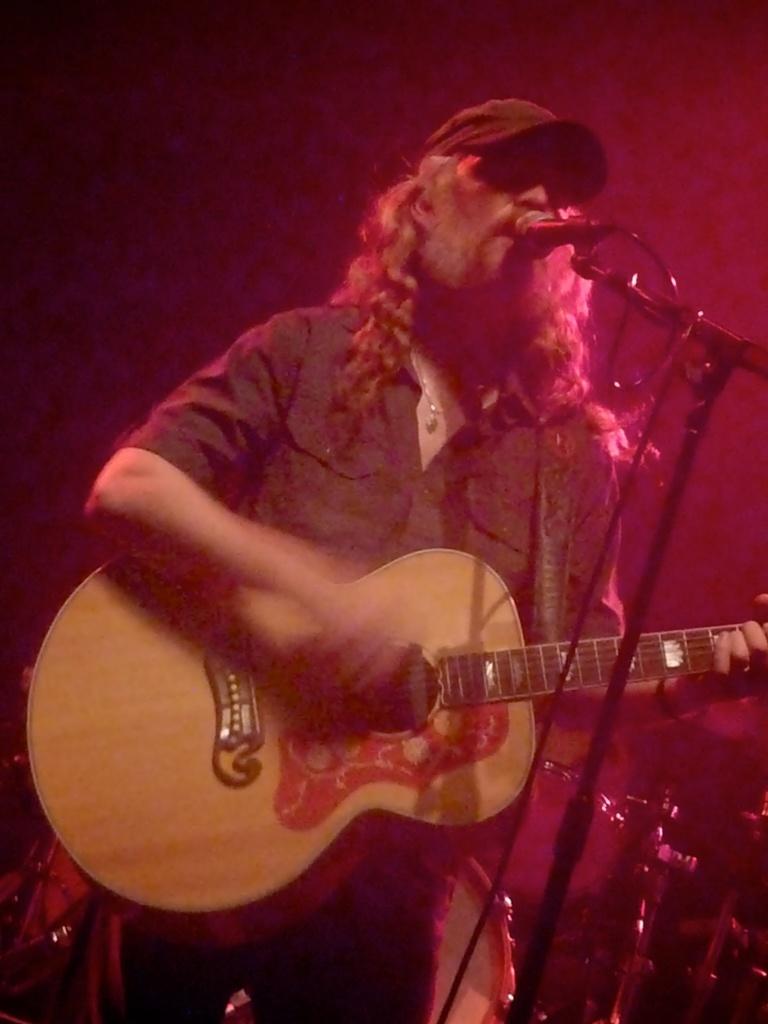Can you describe this image briefly? This picture shows a man playing guitar and singing with the help of a microphone 